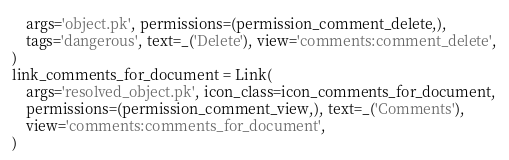Convert code to text. <code><loc_0><loc_0><loc_500><loc_500><_Python_>    args='object.pk', permissions=(permission_comment_delete,),
    tags='dangerous', text=_('Delete'), view='comments:comment_delete',
)
link_comments_for_document = Link(
    args='resolved_object.pk', icon_class=icon_comments_for_document,
    permissions=(permission_comment_view,), text=_('Comments'),
    view='comments:comments_for_document',
)
</code> 